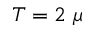Convert formula to latex. <formula><loc_0><loc_0><loc_500><loc_500>T = 2 \mu</formula> 